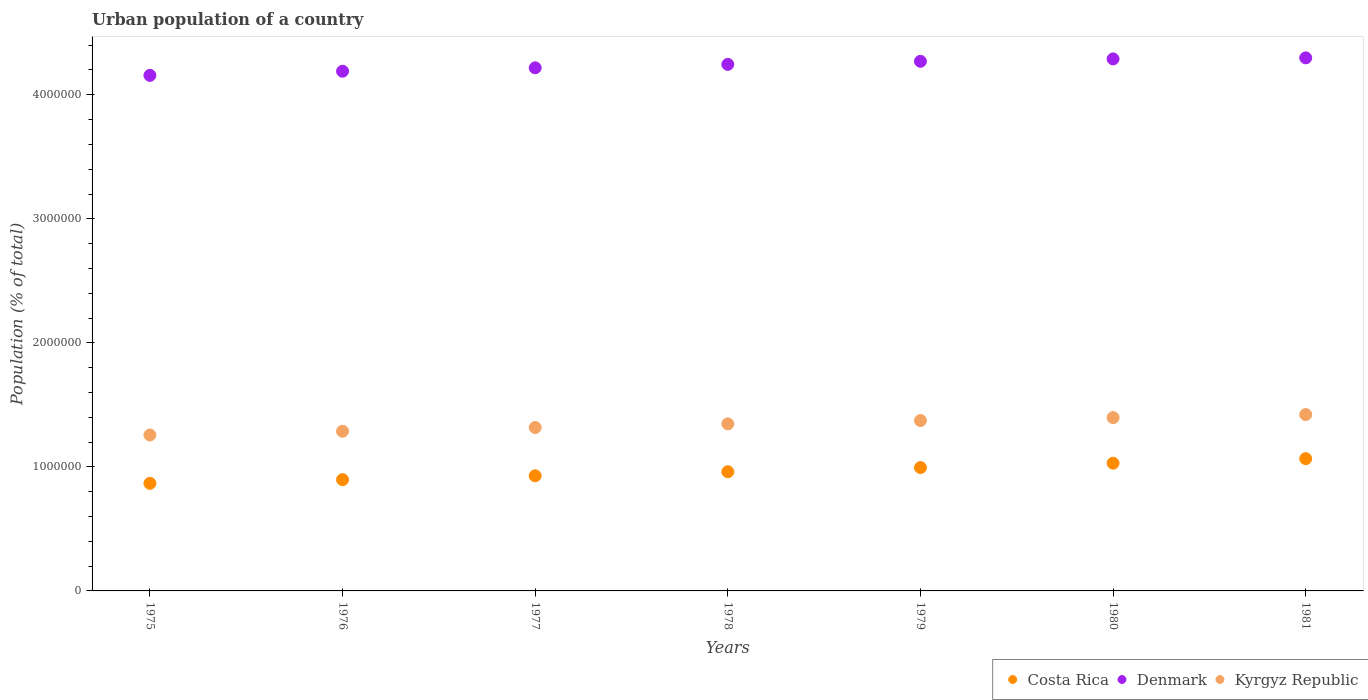How many different coloured dotlines are there?
Your response must be concise. 3. What is the urban population in Costa Rica in 1979?
Provide a succinct answer. 9.95e+05. Across all years, what is the maximum urban population in Costa Rica?
Your response must be concise. 1.07e+06. Across all years, what is the minimum urban population in Denmark?
Your answer should be very brief. 4.16e+06. In which year was the urban population in Kyrgyz Republic minimum?
Provide a short and direct response. 1975. What is the total urban population in Kyrgyz Republic in the graph?
Provide a short and direct response. 9.40e+06. What is the difference between the urban population in Costa Rica in 1977 and that in 1980?
Make the answer very short. -1.02e+05. What is the difference between the urban population in Denmark in 1981 and the urban population in Kyrgyz Republic in 1977?
Provide a succinct answer. 2.98e+06. What is the average urban population in Costa Rica per year?
Provide a short and direct response. 9.63e+05. In the year 1980, what is the difference between the urban population in Kyrgyz Republic and urban population in Denmark?
Provide a succinct answer. -2.89e+06. In how many years, is the urban population in Costa Rica greater than 4000000 %?
Offer a very short reply. 0. What is the ratio of the urban population in Denmark in 1978 to that in 1981?
Your answer should be very brief. 0.99. Is the urban population in Costa Rica in 1978 less than that in 1981?
Ensure brevity in your answer.  Yes. Is the difference between the urban population in Kyrgyz Republic in 1975 and 1980 greater than the difference between the urban population in Denmark in 1975 and 1980?
Give a very brief answer. No. What is the difference between the highest and the second highest urban population in Costa Rica?
Make the answer very short. 3.66e+04. What is the difference between the highest and the lowest urban population in Costa Rica?
Your answer should be compact. 1.99e+05. In how many years, is the urban population in Kyrgyz Republic greater than the average urban population in Kyrgyz Republic taken over all years?
Your answer should be compact. 4. Is it the case that in every year, the sum of the urban population in Kyrgyz Republic and urban population in Denmark  is greater than the urban population in Costa Rica?
Ensure brevity in your answer.  Yes. How many dotlines are there?
Offer a very short reply. 3. What is the difference between two consecutive major ticks on the Y-axis?
Give a very brief answer. 1.00e+06. Are the values on the major ticks of Y-axis written in scientific E-notation?
Your response must be concise. No. Does the graph contain any zero values?
Your response must be concise. No. Does the graph contain grids?
Keep it short and to the point. No. Where does the legend appear in the graph?
Your response must be concise. Bottom right. How many legend labels are there?
Offer a very short reply. 3. How are the legend labels stacked?
Make the answer very short. Horizontal. What is the title of the graph?
Keep it short and to the point. Urban population of a country. What is the label or title of the Y-axis?
Your response must be concise. Population (% of total). What is the Population (% of total) in Costa Rica in 1975?
Offer a very short reply. 8.67e+05. What is the Population (% of total) of Denmark in 1975?
Ensure brevity in your answer.  4.16e+06. What is the Population (% of total) of Kyrgyz Republic in 1975?
Offer a very short reply. 1.26e+06. What is the Population (% of total) in Costa Rica in 1976?
Offer a very short reply. 8.97e+05. What is the Population (% of total) of Denmark in 1976?
Ensure brevity in your answer.  4.19e+06. What is the Population (% of total) of Kyrgyz Republic in 1976?
Offer a terse response. 1.29e+06. What is the Population (% of total) of Costa Rica in 1977?
Your answer should be very brief. 9.28e+05. What is the Population (% of total) of Denmark in 1977?
Give a very brief answer. 4.22e+06. What is the Population (% of total) in Kyrgyz Republic in 1977?
Offer a very short reply. 1.32e+06. What is the Population (% of total) in Costa Rica in 1978?
Offer a terse response. 9.61e+05. What is the Population (% of total) in Denmark in 1978?
Keep it short and to the point. 4.25e+06. What is the Population (% of total) of Kyrgyz Republic in 1978?
Provide a succinct answer. 1.35e+06. What is the Population (% of total) of Costa Rica in 1979?
Your answer should be compact. 9.95e+05. What is the Population (% of total) of Denmark in 1979?
Give a very brief answer. 4.27e+06. What is the Population (% of total) of Kyrgyz Republic in 1979?
Provide a succinct answer. 1.37e+06. What is the Population (% of total) in Costa Rica in 1980?
Offer a terse response. 1.03e+06. What is the Population (% of total) of Denmark in 1980?
Provide a succinct answer. 4.29e+06. What is the Population (% of total) of Kyrgyz Republic in 1980?
Make the answer very short. 1.40e+06. What is the Population (% of total) of Costa Rica in 1981?
Offer a very short reply. 1.07e+06. What is the Population (% of total) of Denmark in 1981?
Offer a terse response. 4.30e+06. What is the Population (% of total) in Kyrgyz Republic in 1981?
Give a very brief answer. 1.42e+06. Across all years, what is the maximum Population (% of total) of Costa Rica?
Provide a short and direct response. 1.07e+06. Across all years, what is the maximum Population (% of total) of Denmark?
Your answer should be very brief. 4.30e+06. Across all years, what is the maximum Population (% of total) in Kyrgyz Republic?
Give a very brief answer. 1.42e+06. Across all years, what is the minimum Population (% of total) of Costa Rica?
Keep it short and to the point. 8.67e+05. Across all years, what is the minimum Population (% of total) in Denmark?
Offer a very short reply. 4.16e+06. Across all years, what is the minimum Population (% of total) in Kyrgyz Republic?
Offer a terse response. 1.26e+06. What is the total Population (% of total) of Costa Rica in the graph?
Provide a succinct answer. 6.74e+06. What is the total Population (% of total) of Denmark in the graph?
Your answer should be very brief. 2.97e+07. What is the total Population (% of total) of Kyrgyz Republic in the graph?
Keep it short and to the point. 9.40e+06. What is the difference between the Population (% of total) of Costa Rica in 1975 and that in 1976?
Your answer should be very brief. -2.99e+04. What is the difference between the Population (% of total) of Denmark in 1975 and that in 1976?
Ensure brevity in your answer.  -3.35e+04. What is the difference between the Population (% of total) of Kyrgyz Republic in 1975 and that in 1976?
Offer a terse response. -3.02e+04. What is the difference between the Population (% of total) in Costa Rica in 1975 and that in 1977?
Your answer should be compact. -6.10e+04. What is the difference between the Population (% of total) in Denmark in 1975 and that in 1977?
Offer a terse response. -6.11e+04. What is the difference between the Population (% of total) in Kyrgyz Republic in 1975 and that in 1977?
Ensure brevity in your answer.  -6.01e+04. What is the difference between the Population (% of total) in Costa Rica in 1975 and that in 1978?
Your response must be concise. -9.35e+04. What is the difference between the Population (% of total) in Denmark in 1975 and that in 1978?
Your answer should be very brief. -8.87e+04. What is the difference between the Population (% of total) of Kyrgyz Republic in 1975 and that in 1978?
Offer a terse response. -8.95e+04. What is the difference between the Population (% of total) of Costa Rica in 1975 and that in 1979?
Keep it short and to the point. -1.27e+05. What is the difference between the Population (% of total) of Denmark in 1975 and that in 1979?
Your answer should be compact. -1.13e+05. What is the difference between the Population (% of total) of Kyrgyz Republic in 1975 and that in 1979?
Your answer should be very brief. -1.17e+05. What is the difference between the Population (% of total) in Costa Rica in 1975 and that in 1980?
Ensure brevity in your answer.  -1.63e+05. What is the difference between the Population (% of total) of Denmark in 1975 and that in 1980?
Ensure brevity in your answer.  -1.33e+05. What is the difference between the Population (% of total) of Kyrgyz Republic in 1975 and that in 1980?
Your answer should be very brief. -1.40e+05. What is the difference between the Population (% of total) of Costa Rica in 1975 and that in 1981?
Make the answer very short. -1.99e+05. What is the difference between the Population (% of total) in Denmark in 1975 and that in 1981?
Your answer should be very brief. -1.41e+05. What is the difference between the Population (% of total) of Kyrgyz Republic in 1975 and that in 1981?
Ensure brevity in your answer.  -1.65e+05. What is the difference between the Population (% of total) of Costa Rica in 1976 and that in 1977?
Your response must be concise. -3.11e+04. What is the difference between the Population (% of total) in Denmark in 1976 and that in 1977?
Your response must be concise. -2.76e+04. What is the difference between the Population (% of total) in Kyrgyz Republic in 1976 and that in 1977?
Provide a short and direct response. -3.00e+04. What is the difference between the Population (% of total) in Costa Rica in 1976 and that in 1978?
Give a very brief answer. -6.36e+04. What is the difference between the Population (% of total) of Denmark in 1976 and that in 1978?
Ensure brevity in your answer.  -5.52e+04. What is the difference between the Population (% of total) of Kyrgyz Republic in 1976 and that in 1978?
Give a very brief answer. -5.93e+04. What is the difference between the Population (% of total) in Costa Rica in 1976 and that in 1979?
Make the answer very short. -9.75e+04. What is the difference between the Population (% of total) in Denmark in 1976 and that in 1979?
Make the answer very short. -7.99e+04. What is the difference between the Population (% of total) in Kyrgyz Republic in 1976 and that in 1979?
Offer a very short reply. -8.64e+04. What is the difference between the Population (% of total) of Costa Rica in 1976 and that in 1980?
Offer a terse response. -1.33e+05. What is the difference between the Population (% of total) in Denmark in 1976 and that in 1980?
Offer a terse response. -9.92e+04. What is the difference between the Population (% of total) in Kyrgyz Republic in 1976 and that in 1980?
Provide a short and direct response. -1.10e+05. What is the difference between the Population (% of total) of Costa Rica in 1976 and that in 1981?
Offer a very short reply. -1.69e+05. What is the difference between the Population (% of total) of Denmark in 1976 and that in 1981?
Provide a succinct answer. -1.08e+05. What is the difference between the Population (% of total) of Kyrgyz Republic in 1976 and that in 1981?
Your answer should be very brief. -1.34e+05. What is the difference between the Population (% of total) in Costa Rica in 1977 and that in 1978?
Your response must be concise. -3.25e+04. What is the difference between the Population (% of total) in Denmark in 1977 and that in 1978?
Your answer should be compact. -2.76e+04. What is the difference between the Population (% of total) of Kyrgyz Republic in 1977 and that in 1978?
Make the answer very short. -2.94e+04. What is the difference between the Population (% of total) in Costa Rica in 1977 and that in 1979?
Offer a very short reply. -6.63e+04. What is the difference between the Population (% of total) of Denmark in 1977 and that in 1979?
Your answer should be very brief. -5.23e+04. What is the difference between the Population (% of total) of Kyrgyz Republic in 1977 and that in 1979?
Offer a terse response. -5.64e+04. What is the difference between the Population (% of total) of Costa Rica in 1977 and that in 1980?
Offer a terse response. -1.02e+05. What is the difference between the Population (% of total) in Denmark in 1977 and that in 1980?
Ensure brevity in your answer.  -7.16e+04. What is the difference between the Population (% of total) in Kyrgyz Republic in 1977 and that in 1980?
Your response must be concise. -7.99e+04. What is the difference between the Population (% of total) in Costa Rica in 1977 and that in 1981?
Give a very brief answer. -1.38e+05. What is the difference between the Population (% of total) of Denmark in 1977 and that in 1981?
Offer a very short reply. -8.02e+04. What is the difference between the Population (% of total) in Kyrgyz Republic in 1977 and that in 1981?
Ensure brevity in your answer.  -1.04e+05. What is the difference between the Population (% of total) of Costa Rica in 1978 and that in 1979?
Keep it short and to the point. -3.38e+04. What is the difference between the Population (% of total) of Denmark in 1978 and that in 1979?
Ensure brevity in your answer.  -2.47e+04. What is the difference between the Population (% of total) of Kyrgyz Republic in 1978 and that in 1979?
Make the answer very short. -2.71e+04. What is the difference between the Population (% of total) of Costa Rica in 1978 and that in 1980?
Your answer should be compact. -6.90e+04. What is the difference between the Population (% of total) of Denmark in 1978 and that in 1980?
Provide a short and direct response. -4.40e+04. What is the difference between the Population (% of total) in Kyrgyz Republic in 1978 and that in 1980?
Ensure brevity in your answer.  -5.05e+04. What is the difference between the Population (% of total) of Costa Rica in 1978 and that in 1981?
Your response must be concise. -1.06e+05. What is the difference between the Population (% of total) in Denmark in 1978 and that in 1981?
Give a very brief answer. -5.26e+04. What is the difference between the Population (% of total) of Kyrgyz Republic in 1978 and that in 1981?
Your response must be concise. -7.51e+04. What is the difference between the Population (% of total) of Costa Rica in 1979 and that in 1980?
Give a very brief answer. -3.52e+04. What is the difference between the Population (% of total) in Denmark in 1979 and that in 1980?
Your response must be concise. -1.93e+04. What is the difference between the Population (% of total) in Kyrgyz Republic in 1979 and that in 1980?
Ensure brevity in your answer.  -2.35e+04. What is the difference between the Population (% of total) in Costa Rica in 1979 and that in 1981?
Provide a succinct answer. -7.17e+04. What is the difference between the Population (% of total) in Denmark in 1979 and that in 1981?
Offer a terse response. -2.79e+04. What is the difference between the Population (% of total) in Kyrgyz Republic in 1979 and that in 1981?
Your response must be concise. -4.81e+04. What is the difference between the Population (% of total) of Costa Rica in 1980 and that in 1981?
Make the answer very short. -3.66e+04. What is the difference between the Population (% of total) of Denmark in 1980 and that in 1981?
Your answer should be very brief. -8615. What is the difference between the Population (% of total) of Kyrgyz Republic in 1980 and that in 1981?
Your answer should be very brief. -2.46e+04. What is the difference between the Population (% of total) in Costa Rica in 1975 and the Population (% of total) in Denmark in 1976?
Your response must be concise. -3.32e+06. What is the difference between the Population (% of total) in Costa Rica in 1975 and the Population (% of total) in Kyrgyz Republic in 1976?
Offer a terse response. -4.20e+05. What is the difference between the Population (% of total) of Denmark in 1975 and the Population (% of total) of Kyrgyz Republic in 1976?
Your answer should be very brief. 2.87e+06. What is the difference between the Population (% of total) of Costa Rica in 1975 and the Population (% of total) of Denmark in 1977?
Offer a very short reply. -3.35e+06. What is the difference between the Population (% of total) of Costa Rica in 1975 and the Population (% of total) of Kyrgyz Republic in 1977?
Offer a very short reply. -4.50e+05. What is the difference between the Population (% of total) in Denmark in 1975 and the Population (% of total) in Kyrgyz Republic in 1977?
Offer a terse response. 2.84e+06. What is the difference between the Population (% of total) in Costa Rica in 1975 and the Population (% of total) in Denmark in 1978?
Your response must be concise. -3.38e+06. What is the difference between the Population (% of total) in Costa Rica in 1975 and the Population (% of total) in Kyrgyz Republic in 1978?
Ensure brevity in your answer.  -4.79e+05. What is the difference between the Population (% of total) of Denmark in 1975 and the Population (% of total) of Kyrgyz Republic in 1978?
Give a very brief answer. 2.81e+06. What is the difference between the Population (% of total) in Costa Rica in 1975 and the Population (% of total) in Denmark in 1979?
Offer a terse response. -3.40e+06. What is the difference between the Population (% of total) of Costa Rica in 1975 and the Population (% of total) of Kyrgyz Republic in 1979?
Provide a short and direct response. -5.07e+05. What is the difference between the Population (% of total) of Denmark in 1975 and the Population (% of total) of Kyrgyz Republic in 1979?
Ensure brevity in your answer.  2.78e+06. What is the difference between the Population (% of total) in Costa Rica in 1975 and the Population (% of total) in Denmark in 1980?
Provide a succinct answer. -3.42e+06. What is the difference between the Population (% of total) of Costa Rica in 1975 and the Population (% of total) of Kyrgyz Republic in 1980?
Provide a succinct answer. -5.30e+05. What is the difference between the Population (% of total) of Denmark in 1975 and the Population (% of total) of Kyrgyz Republic in 1980?
Give a very brief answer. 2.76e+06. What is the difference between the Population (% of total) of Costa Rica in 1975 and the Population (% of total) of Denmark in 1981?
Provide a succinct answer. -3.43e+06. What is the difference between the Population (% of total) in Costa Rica in 1975 and the Population (% of total) in Kyrgyz Republic in 1981?
Provide a short and direct response. -5.55e+05. What is the difference between the Population (% of total) of Denmark in 1975 and the Population (% of total) of Kyrgyz Republic in 1981?
Your answer should be very brief. 2.73e+06. What is the difference between the Population (% of total) in Costa Rica in 1976 and the Population (% of total) in Denmark in 1977?
Provide a succinct answer. -3.32e+06. What is the difference between the Population (% of total) of Costa Rica in 1976 and the Population (% of total) of Kyrgyz Republic in 1977?
Keep it short and to the point. -4.20e+05. What is the difference between the Population (% of total) in Denmark in 1976 and the Population (% of total) in Kyrgyz Republic in 1977?
Keep it short and to the point. 2.87e+06. What is the difference between the Population (% of total) in Costa Rica in 1976 and the Population (% of total) in Denmark in 1978?
Keep it short and to the point. -3.35e+06. What is the difference between the Population (% of total) of Costa Rica in 1976 and the Population (% of total) of Kyrgyz Republic in 1978?
Keep it short and to the point. -4.50e+05. What is the difference between the Population (% of total) of Denmark in 1976 and the Population (% of total) of Kyrgyz Republic in 1978?
Ensure brevity in your answer.  2.84e+06. What is the difference between the Population (% of total) in Costa Rica in 1976 and the Population (% of total) in Denmark in 1979?
Your answer should be very brief. -3.37e+06. What is the difference between the Population (% of total) of Costa Rica in 1976 and the Population (% of total) of Kyrgyz Republic in 1979?
Your answer should be compact. -4.77e+05. What is the difference between the Population (% of total) of Denmark in 1976 and the Population (% of total) of Kyrgyz Republic in 1979?
Your response must be concise. 2.82e+06. What is the difference between the Population (% of total) of Costa Rica in 1976 and the Population (% of total) of Denmark in 1980?
Your answer should be compact. -3.39e+06. What is the difference between the Population (% of total) of Costa Rica in 1976 and the Population (% of total) of Kyrgyz Republic in 1980?
Make the answer very short. -5.00e+05. What is the difference between the Population (% of total) of Denmark in 1976 and the Population (% of total) of Kyrgyz Republic in 1980?
Your answer should be very brief. 2.79e+06. What is the difference between the Population (% of total) of Costa Rica in 1976 and the Population (% of total) of Denmark in 1981?
Make the answer very short. -3.40e+06. What is the difference between the Population (% of total) of Costa Rica in 1976 and the Population (% of total) of Kyrgyz Republic in 1981?
Your answer should be very brief. -5.25e+05. What is the difference between the Population (% of total) of Denmark in 1976 and the Population (% of total) of Kyrgyz Republic in 1981?
Your answer should be very brief. 2.77e+06. What is the difference between the Population (% of total) in Costa Rica in 1977 and the Population (% of total) in Denmark in 1978?
Keep it short and to the point. -3.32e+06. What is the difference between the Population (% of total) of Costa Rica in 1977 and the Population (% of total) of Kyrgyz Republic in 1978?
Offer a terse response. -4.18e+05. What is the difference between the Population (% of total) in Denmark in 1977 and the Population (% of total) in Kyrgyz Republic in 1978?
Your answer should be very brief. 2.87e+06. What is the difference between the Population (% of total) in Costa Rica in 1977 and the Population (% of total) in Denmark in 1979?
Offer a very short reply. -3.34e+06. What is the difference between the Population (% of total) of Costa Rica in 1977 and the Population (% of total) of Kyrgyz Republic in 1979?
Offer a very short reply. -4.46e+05. What is the difference between the Population (% of total) of Denmark in 1977 and the Population (% of total) of Kyrgyz Republic in 1979?
Offer a terse response. 2.84e+06. What is the difference between the Population (% of total) of Costa Rica in 1977 and the Population (% of total) of Denmark in 1980?
Your answer should be compact. -3.36e+06. What is the difference between the Population (% of total) in Costa Rica in 1977 and the Population (% of total) in Kyrgyz Republic in 1980?
Offer a terse response. -4.69e+05. What is the difference between the Population (% of total) in Denmark in 1977 and the Population (% of total) in Kyrgyz Republic in 1980?
Your answer should be very brief. 2.82e+06. What is the difference between the Population (% of total) in Costa Rica in 1977 and the Population (% of total) in Denmark in 1981?
Your answer should be compact. -3.37e+06. What is the difference between the Population (% of total) of Costa Rica in 1977 and the Population (% of total) of Kyrgyz Republic in 1981?
Provide a short and direct response. -4.94e+05. What is the difference between the Population (% of total) of Denmark in 1977 and the Population (% of total) of Kyrgyz Republic in 1981?
Your response must be concise. 2.80e+06. What is the difference between the Population (% of total) of Costa Rica in 1978 and the Population (% of total) of Denmark in 1979?
Keep it short and to the point. -3.31e+06. What is the difference between the Population (% of total) of Costa Rica in 1978 and the Population (% of total) of Kyrgyz Republic in 1979?
Keep it short and to the point. -4.13e+05. What is the difference between the Population (% of total) of Denmark in 1978 and the Population (% of total) of Kyrgyz Republic in 1979?
Provide a short and direct response. 2.87e+06. What is the difference between the Population (% of total) of Costa Rica in 1978 and the Population (% of total) of Denmark in 1980?
Your answer should be very brief. -3.33e+06. What is the difference between the Population (% of total) in Costa Rica in 1978 and the Population (% of total) in Kyrgyz Republic in 1980?
Provide a short and direct response. -4.37e+05. What is the difference between the Population (% of total) of Denmark in 1978 and the Population (% of total) of Kyrgyz Republic in 1980?
Your answer should be very brief. 2.85e+06. What is the difference between the Population (% of total) of Costa Rica in 1978 and the Population (% of total) of Denmark in 1981?
Your response must be concise. -3.34e+06. What is the difference between the Population (% of total) in Costa Rica in 1978 and the Population (% of total) in Kyrgyz Republic in 1981?
Make the answer very short. -4.61e+05. What is the difference between the Population (% of total) of Denmark in 1978 and the Population (% of total) of Kyrgyz Republic in 1981?
Give a very brief answer. 2.82e+06. What is the difference between the Population (% of total) of Costa Rica in 1979 and the Population (% of total) of Denmark in 1980?
Provide a succinct answer. -3.29e+06. What is the difference between the Population (% of total) in Costa Rica in 1979 and the Population (% of total) in Kyrgyz Republic in 1980?
Keep it short and to the point. -4.03e+05. What is the difference between the Population (% of total) of Denmark in 1979 and the Population (% of total) of Kyrgyz Republic in 1980?
Your answer should be compact. 2.87e+06. What is the difference between the Population (% of total) in Costa Rica in 1979 and the Population (% of total) in Denmark in 1981?
Give a very brief answer. -3.30e+06. What is the difference between the Population (% of total) of Costa Rica in 1979 and the Population (% of total) of Kyrgyz Republic in 1981?
Your answer should be compact. -4.27e+05. What is the difference between the Population (% of total) in Denmark in 1979 and the Population (% of total) in Kyrgyz Republic in 1981?
Keep it short and to the point. 2.85e+06. What is the difference between the Population (% of total) in Costa Rica in 1980 and the Population (% of total) in Denmark in 1981?
Provide a short and direct response. -3.27e+06. What is the difference between the Population (% of total) of Costa Rica in 1980 and the Population (% of total) of Kyrgyz Republic in 1981?
Your answer should be very brief. -3.92e+05. What is the difference between the Population (% of total) of Denmark in 1980 and the Population (% of total) of Kyrgyz Republic in 1981?
Give a very brief answer. 2.87e+06. What is the average Population (% of total) of Costa Rica per year?
Give a very brief answer. 9.63e+05. What is the average Population (% of total) of Denmark per year?
Your answer should be very brief. 4.24e+06. What is the average Population (% of total) of Kyrgyz Republic per year?
Your answer should be very brief. 1.34e+06. In the year 1975, what is the difference between the Population (% of total) of Costa Rica and Population (% of total) of Denmark?
Provide a short and direct response. -3.29e+06. In the year 1975, what is the difference between the Population (% of total) in Costa Rica and Population (% of total) in Kyrgyz Republic?
Provide a succinct answer. -3.90e+05. In the year 1975, what is the difference between the Population (% of total) in Denmark and Population (% of total) in Kyrgyz Republic?
Make the answer very short. 2.90e+06. In the year 1976, what is the difference between the Population (% of total) in Costa Rica and Population (% of total) in Denmark?
Give a very brief answer. -3.29e+06. In the year 1976, what is the difference between the Population (% of total) in Costa Rica and Population (% of total) in Kyrgyz Republic?
Ensure brevity in your answer.  -3.90e+05. In the year 1976, what is the difference between the Population (% of total) in Denmark and Population (% of total) in Kyrgyz Republic?
Your answer should be very brief. 2.90e+06. In the year 1977, what is the difference between the Population (% of total) of Costa Rica and Population (% of total) of Denmark?
Provide a succinct answer. -3.29e+06. In the year 1977, what is the difference between the Population (% of total) of Costa Rica and Population (% of total) of Kyrgyz Republic?
Your response must be concise. -3.89e+05. In the year 1977, what is the difference between the Population (% of total) of Denmark and Population (% of total) of Kyrgyz Republic?
Offer a terse response. 2.90e+06. In the year 1978, what is the difference between the Population (% of total) of Costa Rica and Population (% of total) of Denmark?
Provide a succinct answer. -3.28e+06. In the year 1978, what is the difference between the Population (% of total) in Costa Rica and Population (% of total) in Kyrgyz Republic?
Your answer should be very brief. -3.86e+05. In the year 1978, what is the difference between the Population (% of total) of Denmark and Population (% of total) of Kyrgyz Republic?
Provide a succinct answer. 2.90e+06. In the year 1979, what is the difference between the Population (% of total) in Costa Rica and Population (% of total) in Denmark?
Provide a succinct answer. -3.28e+06. In the year 1979, what is the difference between the Population (% of total) in Costa Rica and Population (% of total) in Kyrgyz Republic?
Provide a succinct answer. -3.79e+05. In the year 1979, what is the difference between the Population (% of total) in Denmark and Population (% of total) in Kyrgyz Republic?
Your answer should be very brief. 2.90e+06. In the year 1980, what is the difference between the Population (% of total) in Costa Rica and Population (% of total) in Denmark?
Keep it short and to the point. -3.26e+06. In the year 1980, what is the difference between the Population (% of total) of Costa Rica and Population (% of total) of Kyrgyz Republic?
Keep it short and to the point. -3.68e+05. In the year 1980, what is the difference between the Population (% of total) of Denmark and Population (% of total) of Kyrgyz Republic?
Give a very brief answer. 2.89e+06. In the year 1981, what is the difference between the Population (% of total) in Costa Rica and Population (% of total) in Denmark?
Ensure brevity in your answer.  -3.23e+06. In the year 1981, what is the difference between the Population (% of total) in Costa Rica and Population (% of total) in Kyrgyz Republic?
Provide a short and direct response. -3.56e+05. In the year 1981, what is the difference between the Population (% of total) of Denmark and Population (% of total) of Kyrgyz Republic?
Give a very brief answer. 2.88e+06. What is the ratio of the Population (% of total) of Costa Rica in 1975 to that in 1976?
Offer a very short reply. 0.97. What is the ratio of the Population (% of total) of Kyrgyz Republic in 1975 to that in 1976?
Your response must be concise. 0.98. What is the ratio of the Population (% of total) of Costa Rica in 1975 to that in 1977?
Offer a terse response. 0.93. What is the ratio of the Population (% of total) in Denmark in 1975 to that in 1977?
Make the answer very short. 0.99. What is the ratio of the Population (% of total) in Kyrgyz Republic in 1975 to that in 1977?
Your answer should be very brief. 0.95. What is the ratio of the Population (% of total) of Costa Rica in 1975 to that in 1978?
Your response must be concise. 0.9. What is the ratio of the Population (% of total) of Denmark in 1975 to that in 1978?
Offer a terse response. 0.98. What is the ratio of the Population (% of total) in Kyrgyz Republic in 1975 to that in 1978?
Offer a very short reply. 0.93. What is the ratio of the Population (% of total) of Costa Rica in 1975 to that in 1979?
Your answer should be very brief. 0.87. What is the ratio of the Population (% of total) in Denmark in 1975 to that in 1979?
Your answer should be very brief. 0.97. What is the ratio of the Population (% of total) in Kyrgyz Republic in 1975 to that in 1979?
Ensure brevity in your answer.  0.92. What is the ratio of the Population (% of total) of Costa Rica in 1975 to that in 1980?
Provide a short and direct response. 0.84. What is the ratio of the Population (% of total) in Denmark in 1975 to that in 1980?
Ensure brevity in your answer.  0.97. What is the ratio of the Population (% of total) in Kyrgyz Republic in 1975 to that in 1980?
Ensure brevity in your answer.  0.9. What is the ratio of the Population (% of total) of Costa Rica in 1975 to that in 1981?
Offer a terse response. 0.81. What is the ratio of the Population (% of total) of Denmark in 1975 to that in 1981?
Make the answer very short. 0.97. What is the ratio of the Population (% of total) in Kyrgyz Republic in 1975 to that in 1981?
Offer a terse response. 0.88. What is the ratio of the Population (% of total) of Costa Rica in 1976 to that in 1977?
Give a very brief answer. 0.97. What is the ratio of the Population (% of total) of Kyrgyz Republic in 1976 to that in 1977?
Give a very brief answer. 0.98. What is the ratio of the Population (% of total) of Costa Rica in 1976 to that in 1978?
Provide a short and direct response. 0.93. What is the ratio of the Population (% of total) of Denmark in 1976 to that in 1978?
Offer a very short reply. 0.99. What is the ratio of the Population (% of total) of Kyrgyz Republic in 1976 to that in 1978?
Your response must be concise. 0.96. What is the ratio of the Population (% of total) in Costa Rica in 1976 to that in 1979?
Your response must be concise. 0.9. What is the ratio of the Population (% of total) in Denmark in 1976 to that in 1979?
Your response must be concise. 0.98. What is the ratio of the Population (% of total) in Kyrgyz Republic in 1976 to that in 1979?
Offer a very short reply. 0.94. What is the ratio of the Population (% of total) of Costa Rica in 1976 to that in 1980?
Give a very brief answer. 0.87. What is the ratio of the Population (% of total) in Denmark in 1976 to that in 1980?
Offer a terse response. 0.98. What is the ratio of the Population (% of total) in Kyrgyz Republic in 1976 to that in 1980?
Make the answer very short. 0.92. What is the ratio of the Population (% of total) of Costa Rica in 1976 to that in 1981?
Your answer should be compact. 0.84. What is the ratio of the Population (% of total) of Denmark in 1976 to that in 1981?
Provide a short and direct response. 0.97. What is the ratio of the Population (% of total) of Kyrgyz Republic in 1976 to that in 1981?
Ensure brevity in your answer.  0.91. What is the ratio of the Population (% of total) in Costa Rica in 1977 to that in 1978?
Your answer should be very brief. 0.97. What is the ratio of the Population (% of total) of Denmark in 1977 to that in 1978?
Provide a short and direct response. 0.99. What is the ratio of the Population (% of total) of Kyrgyz Republic in 1977 to that in 1978?
Your answer should be very brief. 0.98. What is the ratio of the Population (% of total) of Kyrgyz Republic in 1977 to that in 1979?
Give a very brief answer. 0.96. What is the ratio of the Population (% of total) of Costa Rica in 1977 to that in 1980?
Ensure brevity in your answer.  0.9. What is the ratio of the Population (% of total) of Denmark in 1977 to that in 1980?
Provide a succinct answer. 0.98. What is the ratio of the Population (% of total) of Kyrgyz Republic in 1977 to that in 1980?
Your answer should be very brief. 0.94. What is the ratio of the Population (% of total) of Costa Rica in 1977 to that in 1981?
Your answer should be very brief. 0.87. What is the ratio of the Population (% of total) of Denmark in 1977 to that in 1981?
Offer a terse response. 0.98. What is the ratio of the Population (% of total) of Kyrgyz Republic in 1977 to that in 1981?
Provide a short and direct response. 0.93. What is the ratio of the Population (% of total) of Costa Rica in 1978 to that in 1979?
Keep it short and to the point. 0.97. What is the ratio of the Population (% of total) of Kyrgyz Republic in 1978 to that in 1979?
Ensure brevity in your answer.  0.98. What is the ratio of the Population (% of total) of Costa Rica in 1978 to that in 1980?
Your answer should be very brief. 0.93. What is the ratio of the Population (% of total) of Kyrgyz Republic in 1978 to that in 1980?
Your response must be concise. 0.96. What is the ratio of the Population (% of total) in Costa Rica in 1978 to that in 1981?
Offer a terse response. 0.9. What is the ratio of the Population (% of total) in Denmark in 1978 to that in 1981?
Make the answer very short. 0.99. What is the ratio of the Population (% of total) in Kyrgyz Republic in 1978 to that in 1981?
Provide a succinct answer. 0.95. What is the ratio of the Population (% of total) in Costa Rica in 1979 to that in 1980?
Offer a terse response. 0.97. What is the ratio of the Population (% of total) in Kyrgyz Republic in 1979 to that in 1980?
Provide a succinct answer. 0.98. What is the ratio of the Population (% of total) of Costa Rica in 1979 to that in 1981?
Ensure brevity in your answer.  0.93. What is the ratio of the Population (% of total) of Kyrgyz Republic in 1979 to that in 1981?
Your response must be concise. 0.97. What is the ratio of the Population (% of total) of Costa Rica in 1980 to that in 1981?
Ensure brevity in your answer.  0.97. What is the ratio of the Population (% of total) in Kyrgyz Republic in 1980 to that in 1981?
Provide a short and direct response. 0.98. What is the difference between the highest and the second highest Population (% of total) in Costa Rica?
Provide a short and direct response. 3.66e+04. What is the difference between the highest and the second highest Population (% of total) in Denmark?
Offer a very short reply. 8615. What is the difference between the highest and the second highest Population (% of total) of Kyrgyz Republic?
Your answer should be compact. 2.46e+04. What is the difference between the highest and the lowest Population (% of total) of Costa Rica?
Offer a very short reply. 1.99e+05. What is the difference between the highest and the lowest Population (% of total) of Denmark?
Keep it short and to the point. 1.41e+05. What is the difference between the highest and the lowest Population (% of total) in Kyrgyz Republic?
Make the answer very short. 1.65e+05. 